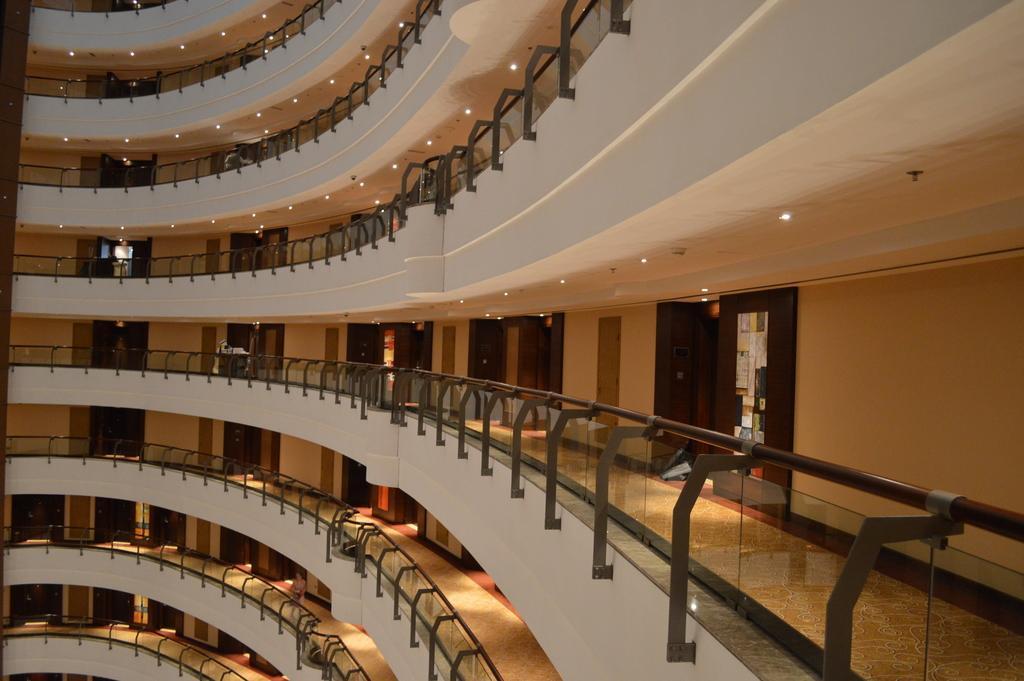Describe this image in one or two sentences. In this image on the right, there is a building on that there are doors, lights and wall. 